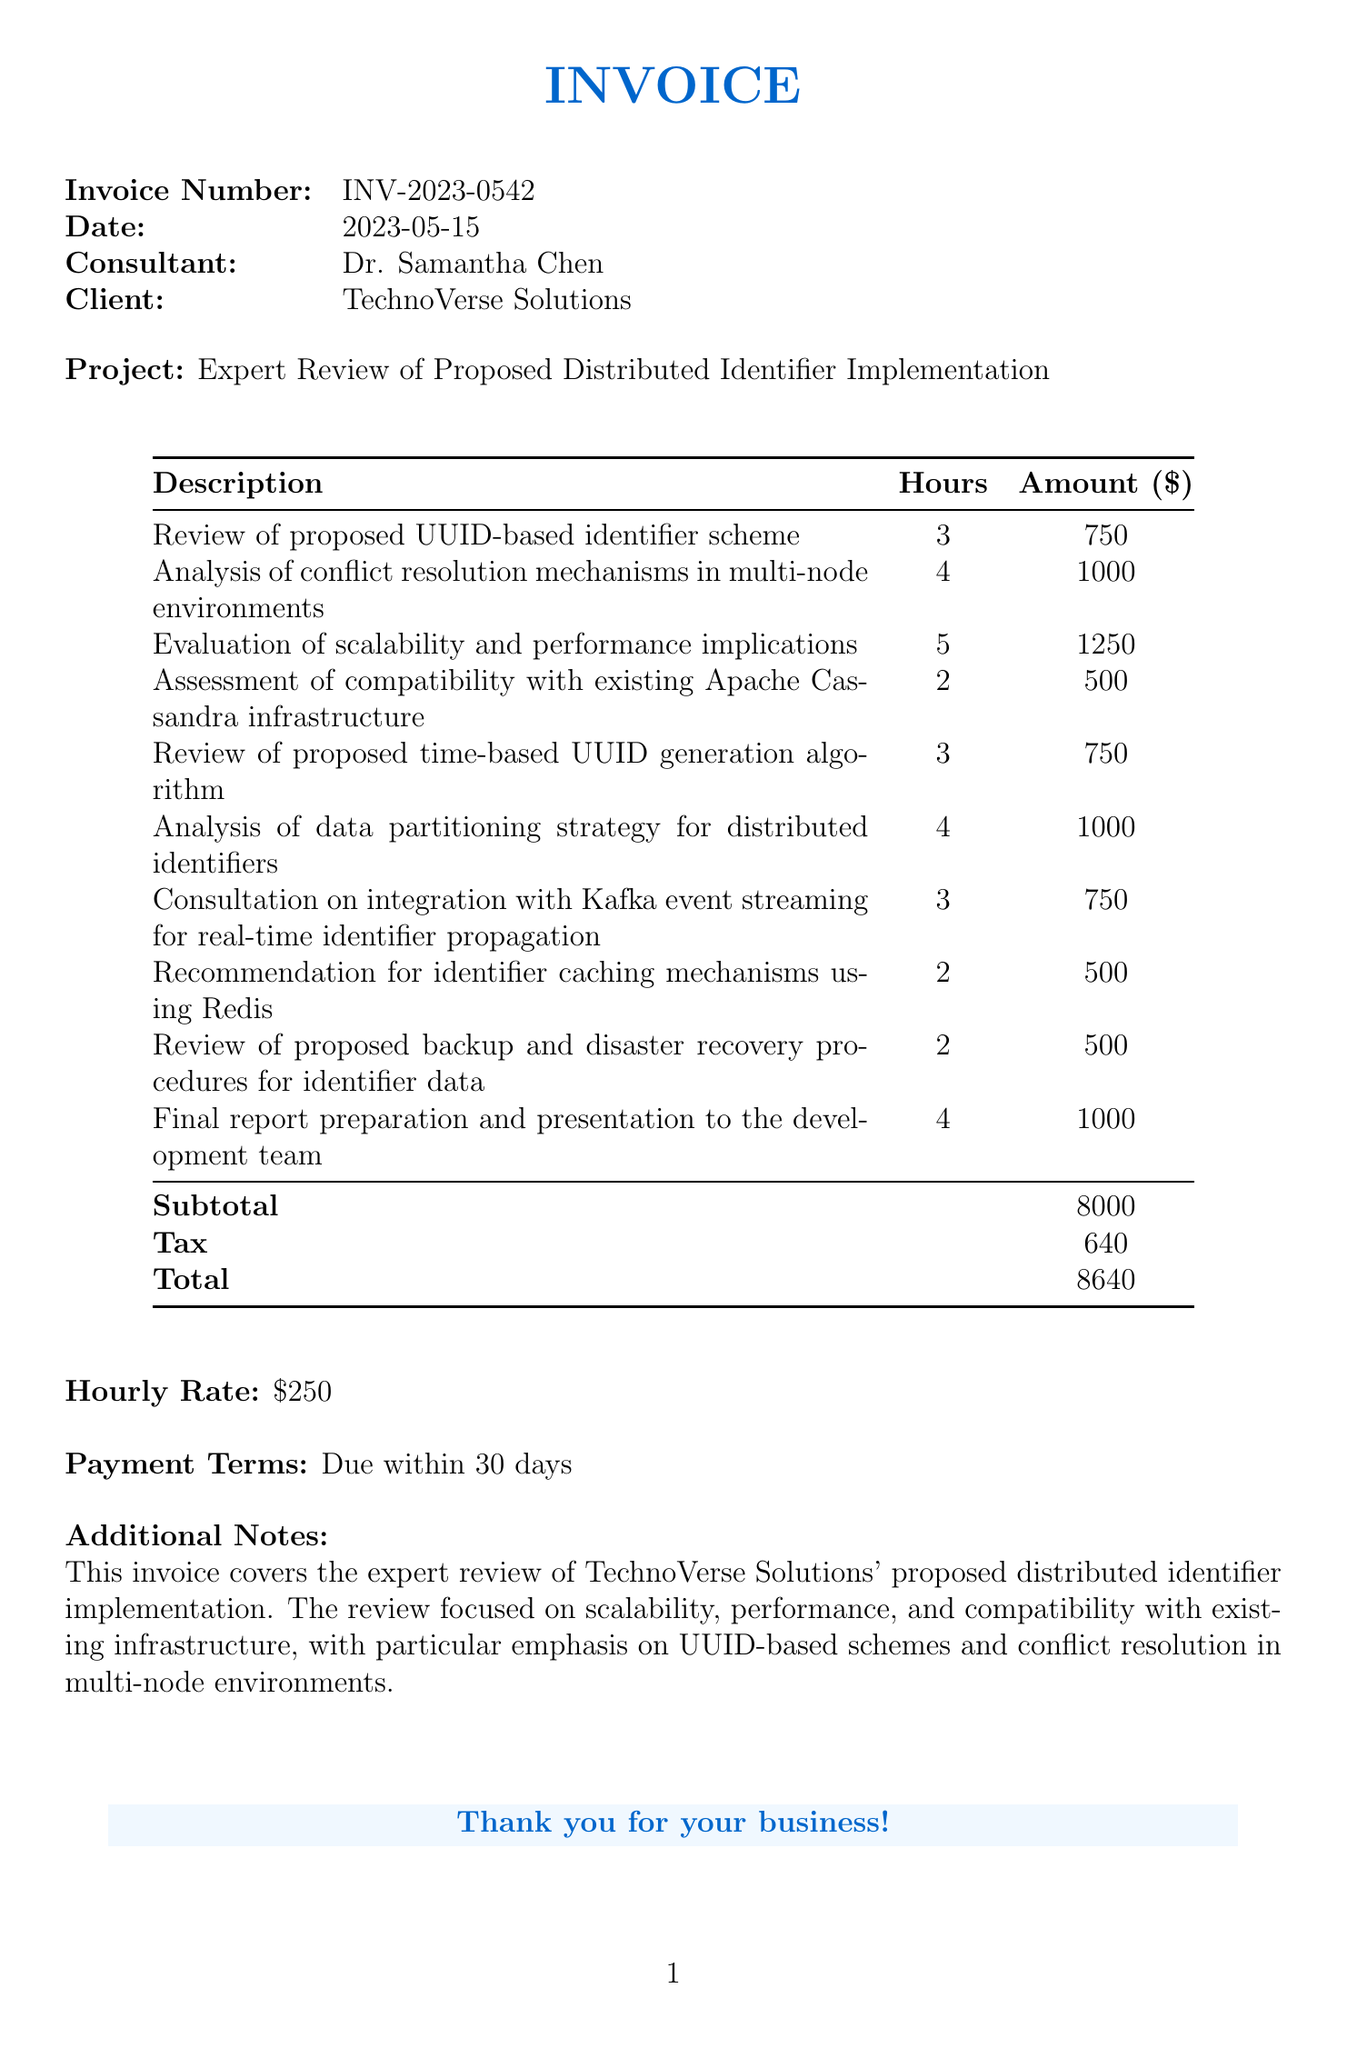What is the invoice number? The invoice number is explicitly stated at the top of the document.
Answer: INV-2023-0542 Who is the consultant? The consultant's name is provided in the invoice details section.
Answer: Dr. Samantha Chen What is the total amount due? The total amount is calculated and presented at the end of the invoice.
Answer: 8640 How many hours were spent on the evaluation of scalability and performance implications? The number of hours for this line item is noted in the corresponding row.
Answer: 5 What is the hourly rate charged by the consultant? The hourly rate is indicated separately on the invoice.
Answer: 250 Which infrastructure compatibility was assessed? The specific infrastructure that was assessed is mentioned in one of the line items.
Answer: Apache Cassandra What was the subtotal before tax? The subtotal is a key figure listed in the summary table of the invoice.
Answer: 8000 How many line items are related to UUID-based schemes? The line items specifically focusing on UUID-based schemes can be counted from the document.
Answer: 2 What are the payment terms set for this invoice? The payment terms are clearly outlined in the document under payment terms.
Answer: Due within 30 days 